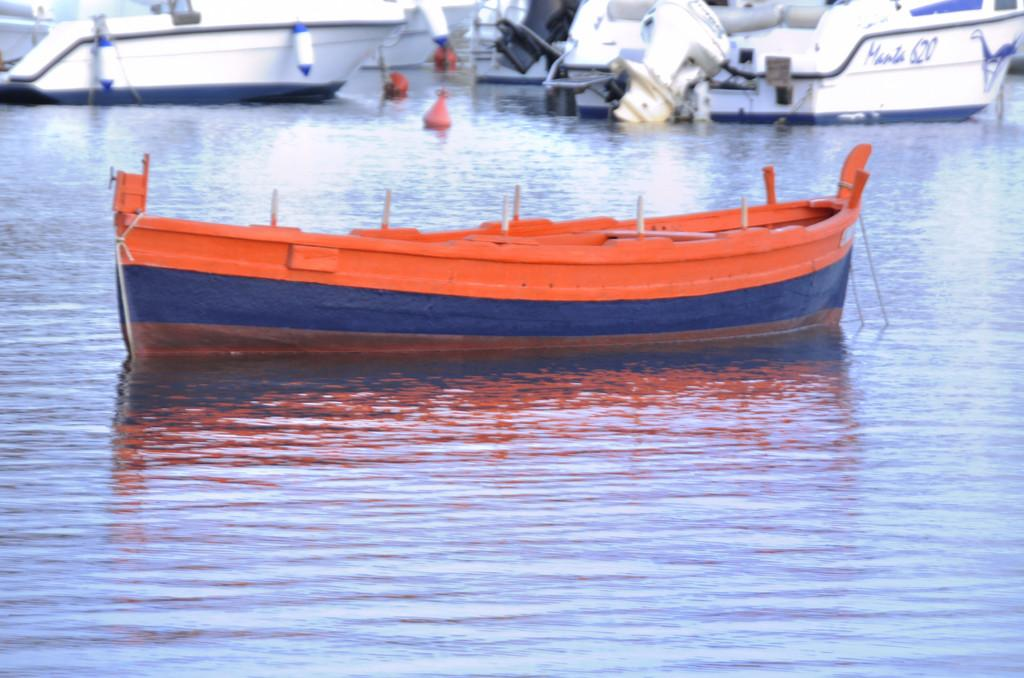Provide a one-sentence caption for the provided image. A red and blue row boat is in front of a white boat that says manta 620. 